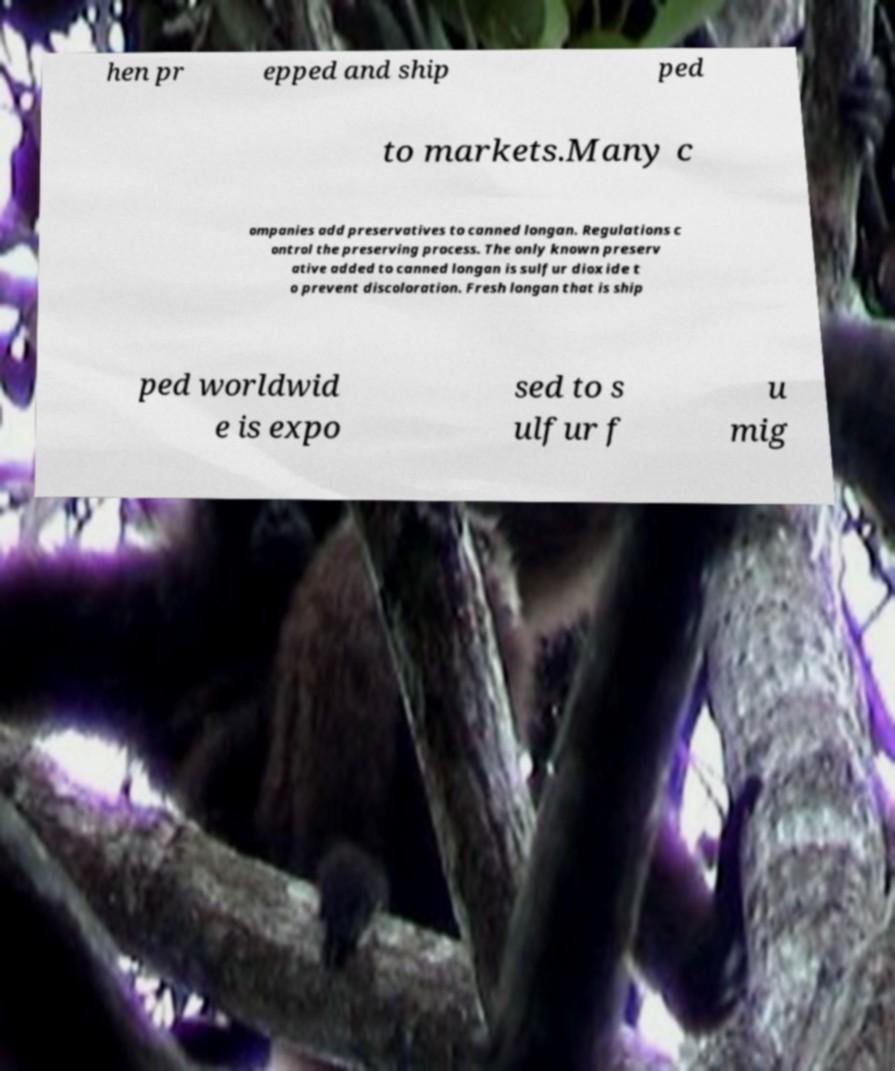Could you extract and type out the text from this image? hen pr epped and ship ped to markets.Many c ompanies add preservatives to canned longan. Regulations c ontrol the preserving process. The only known preserv ative added to canned longan is sulfur dioxide t o prevent discoloration. Fresh longan that is ship ped worldwid e is expo sed to s ulfur f u mig 